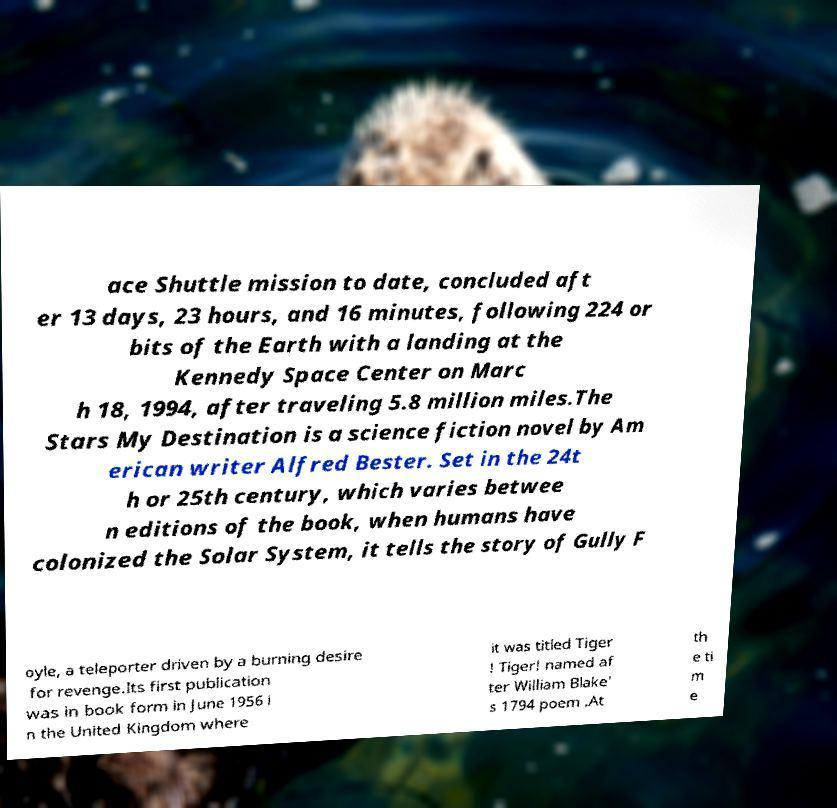There's text embedded in this image that I need extracted. Can you transcribe it verbatim? ace Shuttle mission to date, concluded aft er 13 days, 23 hours, and 16 minutes, following 224 or bits of the Earth with a landing at the Kennedy Space Center on Marc h 18, 1994, after traveling 5.8 million miles.The Stars My Destination is a science fiction novel by Am erican writer Alfred Bester. Set in the 24t h or 25th century, which varies betwee n editions of the book, when humans have colonized the Solar System, it tells the story of Gully F oyle, a teleporter driven by a burning desire for revenge.Its first publication was in book form in June 1956 i n the United Kingdom where it was titled Tiger ! Tiger! named af ter William Blake' s 1794 poem .At th e ti m e 